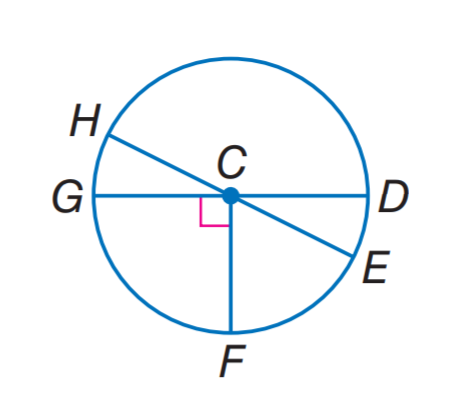Question: In \odot C, m \angle H C G = 2 x and m \angle H C D = 6 x + 28, find m \widehat H D.
Choices:
A. 128
B. 134
C. 142
D. 166
Answer with the letter. Answer: C Question: In \odot C, m \angle H C G = 2 x and m \angle H C D = 6 x + 28, find m \widehat E F.
Choices:
A. 38
B. 52
C. 68
D. 142
Answer with the letter. Answer: B 